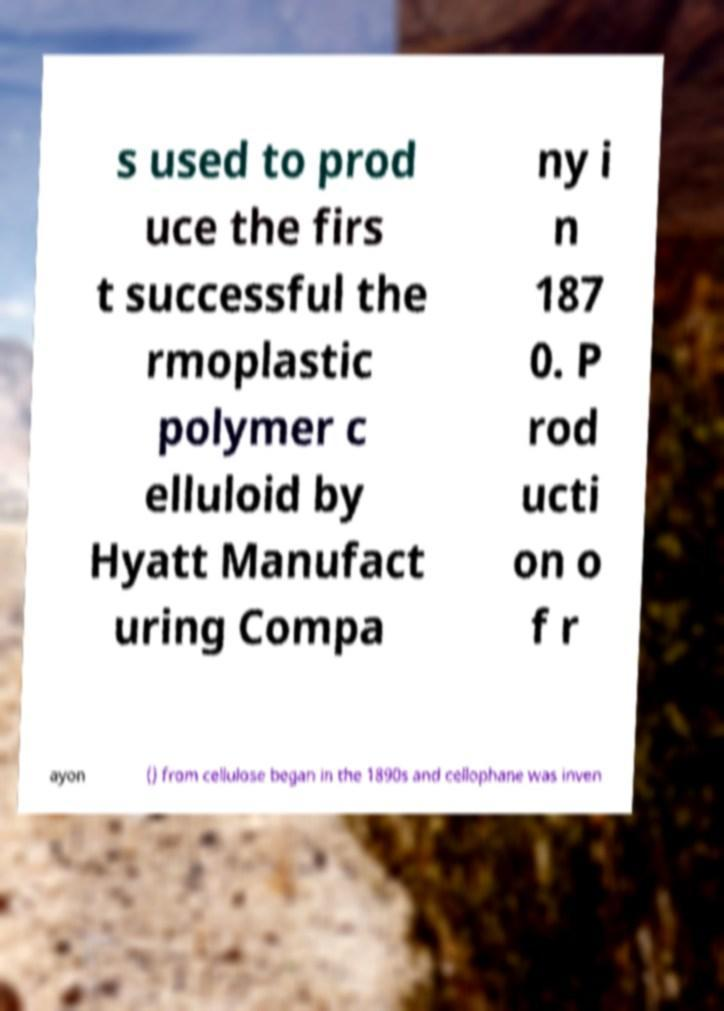There's text embedded in this image that I need extracted. Can you transcribe it verbatim? s used to prod uce the firs t successful the rmoplastic polymer c elluloid by Hyatt Manufact uring Compa ny i n 187 0. P rod ucti on o f r ayon () from cellulose began in the 1890s and cellophane was inven 